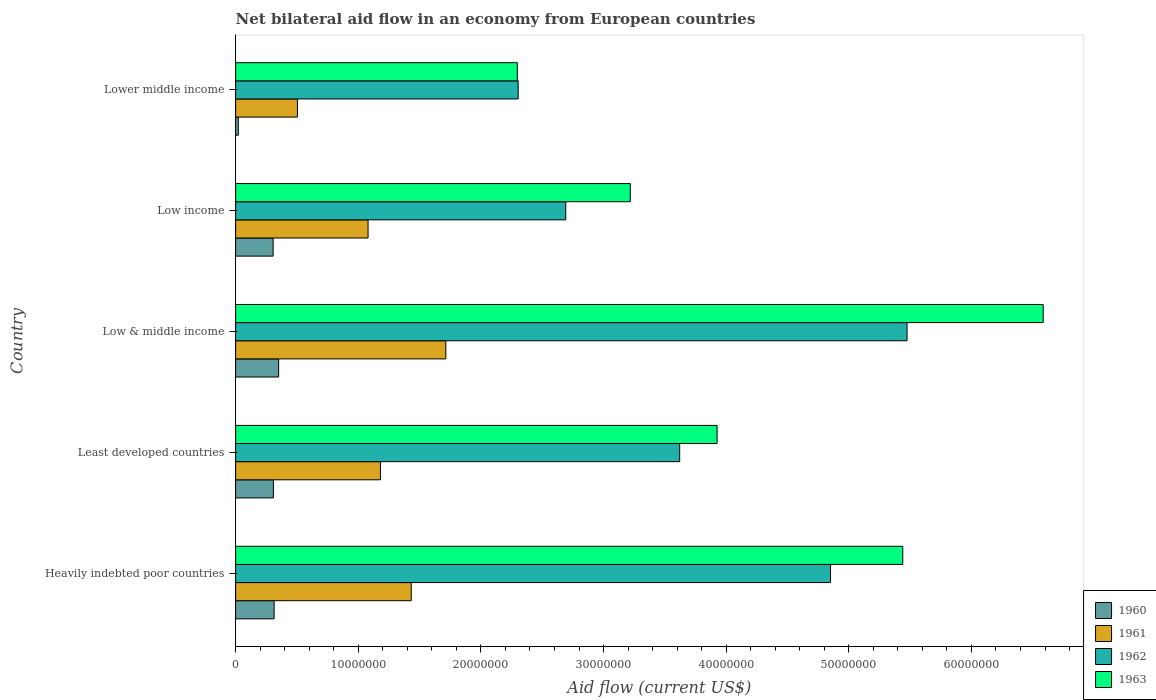How many different coloured bars are there?
Offer a terse response. 4. How many groups of bars are there?
Your answer should be compact. 5. Are the number of bars per tick equal to the number of legend labels?
Offer a terse response. Yes. Are the number of bars on each tick of the Y-axis equal?
Give a very brief answer. Yes. How many bars are there on the 5th tick from the top?
Make the answer very short. 4. In how many cases, is the number of bars for a given country not equal to the number of legend labels?
Make the answer very short. 0. What is the net bilateral aid flow in 1962 in Heavily indebted poor countries?
Offer a very short reply. 4.85e+07. Across all countries, what is the maximum net bilateral aid flow in 1963?
Provide a succinct answer. 6.58e+07. Across all countries, what is the minimum net bilateral aid flow in 1962?
Your answer should be compact. 2.30e+07. In which country was the net bilateral aid flow in 1961 minimum?
Give a very brief answer. Lower middle income. What is the total net bilateral aid flow in 1963 in the graph?
Keep it short and to the point. 2.15e+08. What is the difference between the net bilateral aid flow in 1960 in Least developed countries and that in Lower middle income?
Provide a succinct answer. 2.86e+06. What is the difference between the net bilateral aid flow in 1962 in Heavily indebted poor countries and the net bilateral aid flow in 1963 in Low & middle income?
Provide a succinct answer. -1.73e+07. What is the average net bilateral aid flow in 1963 per country?
Your answer should be very brief. 4.29e+07. What is the difference between the net bilateral aid flow in 1960 and net bilateral aid flow in 1962 in Low & middle income?
Make the answer very short. -5.12e+07. What is the ratio of the net bilateral aid flow in 1962 in Least developed countries to that in Low income?
Your response must be concise. 1.35. Is the difference between the net bilateral aid flow in 1960 in Least developed countries and Lower middle income greater than the difference between the net bilateral aid flow in 1962 in Least developed countries and Lower middle income?
Ensure brevity in your answer.  No. What is the difference between the highest and the second highest net bilateral aid flow in 1962?
Offer a terse response. 6.24e+06. What is the difference between the highest and the lowest net bilateral aid flow in 1960?
Your answer should be very brief. 3.29e+06. In how many countries, is the net bilateral aid flow in 1961 greater than the average net bilateral aid flow in 1961 taken over all countries?
Make the answer very short. 2. What does the 4th bar from the bottom in Low & middle income represents?
Offer a terse response. 1963. Is it the case that in every country, the sum of the net bilateral aid flow in 1962 and net bilateral aid flow in 1960 is greater than the net bilateral aid flow in 1963?
Ensure brevity in your answer.  No. Are all the bars in the graph horizontal?
Offer a terse response. Yes. What is the difference between two consecutive major ticks on the X-axis?
Your answer should be compact. 1.00e+07. Does the graph contain grids?
Keep it short and to the point. No. How many legend labels are there?
Make the answer very short. 4. How are the legend labels stacked?
Keep it short and to the point. Vertical. What is the title of the graph?
Your response must be concise. Net bilateral aid flow in an economy from European countries. What is the label or title of the X-axis?
Make the answer very short. Aid flow (current US$). What is the label or title of the Y-axis?
Ensure brevity in your answer.  Country. What is the Aid flow (current US$) of 1960 in Heavily indebted poor countries?
Provide a short and direct response. 3.14e+06. What is the Aid flow (current US$) of 1961 in Heavily indebted poor countries?
Offer a terse response. 1.43e+07. What is the Aid flow (current US$) in 1962 in Heavily indebted poor countries?
Ensure brevity in your answer.  4.85e+07. What is the Aid flow (current US$) in 1963 in Heavily indebted poor countries?
Your response must be concise. 5.44e+07. What is the Aid flow (current US$) of 1960 in Least developed countries?
Provide a short and direct response. 3.08e+06. What is the Aid flow (current US$) of 1961 in Least developed countries?
Provide a succinct answer. 1.18e+07. What is the Aid flow (current US$) of 1962 in Least developed countries?
Provide a short and direct response. 3.62e+07. What is the Aid flow (current US$) of 1963 in Least developed countries?
Offer a terse response. 3.93e+07. What is the Aid flow (current US$) in 1960 in Low & middle income?
Offer a terse response. 3.51e+06. What is the Aid flow (current US$) of 1961 in Low & middle income?
Provide a short and direct response. 1.71e+07. What is the Aid flow (current US$) in 1962 in Low & middle income?
Your response must be concise. 5.48e+07. What is the Aid flow (current US$) in 1963 in Low & middle income?
Your response must be concise. 6.58e+07. What is the Aid flow (current US$) of 1960 in Low income?
Your answer should be compact. 3.06e+06. What is the Aid flow (current US$) in 1961 in Low income?
Your answer should be compact. 1.08e+07. What is the Aid flow (current US$) of 1962 in Low income?
Ensure brevity in your answer.  2.69e+07. What is the Aid flow (current US$) in 1963 in Low income?
Your response must be concise. 3.22e+07. What is the Aid flow (current US$) in 1961 in Lower middle income?
Offer a terse response. 5.04e+06. What is the Aid flow (current US$) in 1962 in Lower middle income?
Provide a succinct answer. 2.30e+07. What is the Aid flow (current US$) of 1963 in Lower middle income?
Your answer should be very brief. 2.30e+07. Across all countries, what is the maximum Aid flow (current US$) in 1960?
Offer a very short reply. 3.51e+06. Across all countries, what is the maximum Aid flow (current US$) of 1961?
Ensure brevity in your answer.  1.71e+07. Across all countries, what is the maximum Aid flow (current US$) in 1962?
Your response must be concise. 5.48e+07. Across all countries, what is the maximum Aid flow (current US$) in 1963?
Offer a terse response. 6.58e+07. Across all countries, what is the minimum Aid flow (current US$) in 1960?
Offer a terse response. 2.20e+05. Across all countries, what is the minimum Aid flow (current US$) in 1961?
Offer a very short reply. 5.04e+06. Across all countries, what is the minimum Aid flow (current US$) of 1962?
Keep it short and to the point. 2.30e+07. Across all countries, what is the minimum Aid flow (current US$) of 1963?
Give a very brief answer. 2.30e+07. What is the total Aid flow (current US$) of 1960 in the graph?
Give a very brief answer. 1.30e+07. What is the total Aid flow (current US$) in 1961 in the graph?
Your answer should be very brief. 5.91e+07. What is the total Aid flow (current US$) of 1962 in the graph?
Ensure brevity in your answer.  1.89e+08. What is the total Aid flow (current US$) in 1963 in the graph?
Your response must be concise. 2.15e+08. What is the difference between the Aid flow (current US$) of 1961 in Heavily indebted poor countries and that in Least developed countries?
Offer a terse response. 2.51e+06. What is the difference between the Aid flow (current US$) of 1962 in Heavily indebted poor countries and that in Least developed countries?
Offer a terse response. 1.23e+07. What is the difference between the Aid flow (current US$) of 1963 in Heavily indebted poor countries and that in Least developed countries?
Provide a short and direct response. 1.51e+07. What is the difference between the Aid flow (current US$) in 1960 in Heavily indebted poor countries and that in Low & middle income?
Give a very brief answer. -3.70e+05. What is the difference between the Aid flow (current US$) in 1961 in Heavily indebted poor countries and that in Low & middle income?
Provide a short and direct response. -2.82e+06. What is the difference between the Aid flow (current US$) of 1962 in Heavily indebted poor countries and that in Low & middle income?
Make the answer very short. -6.24e+06. What is the difference between the Aid flow (current US$) in 1963 in Heavily indebted poor countries and that in Low & middle income?
Give a very brief answer. -1.14e+07. What is the difference between the Aid flow (current US$) in 1961 in Heavily indebted poor countries and that in Low income?
Give a very brief answer. 3.52e+06. What is the difference between the Aid flow (current US$) of 1962 in Heavily indebted poor countries and that in Low income?
Offer a terse response. 2.16e+07. What is the difference between the Aid flow (current US$) of 1963 in Heavily indebted poor countries and that in Low income?
Keep it short and to the point. 2.22e+07. What is the difference between the Aid flow (current US$) of 1960 in Heavily indebted poor countries and that in Lower middle income?
Provide a succinct answer. 2.92e+06. What is the difference between the Aid flow (current US$) in 1961 in Heavily indebted poor countries and that in Lower middle income?
Offer a very short reply. 9.28e+06. What is the difference between the Aid flow (current US$) of 1962 in Heavily indebted poor countries and that in Lower middle income?
Make the answer very short. 2.55e+07. What is the difference between the Aid flow (current US$) in 1963 in Heavily indebted poor countries and that in Lower middle income?
Make the answer very short. 3.14e+07. What is the difference between the Aid flow (current US$) in 1960 in Least developed countries and that in Low & middle income?
Provide a succinct answer. -4.30e+05. What is the difference between the Aid flow (current US$) of 1961 in Least developed countries and that in Low & middle income?
Ensure brevity in your answer.  -5.33e+06. What is the difference between the Aid flow (current US$) in 1962 in Least developed countries and that in Low & middle income?
Offer a very short reply. -1.85e+07. What is the difference between the Aid flow (current US$) of 1963 in Least developed countries and that in Low & middle income?
Your response must be concise. -2.66e+07. What is the difference between the Aid flow (current US$) in 1960 in Least developed countries and that in Low income?
Give a very brief answer. 2.00e+04. What is the difference between the Aid flow (current US$) in 1961 in Least developed countries and that in Low income?
Provide a succinct answer. 1.01e+06. What is the difference between the Aid flow (current US$) in 1962 in Least developed countries and that in Low income?
Your answer should be very brief. 9.29e+06. What is the difference between the Aid flow (current US$) in 1963 in Least developed countries and that in Low income?
Keep it short and to the point. 7.08e+06. What is the difference between the Aid flow (current US$) of 1960 in Least developed countries and that in Lower middle income?
Your response must be concise. 2.86e+06. What is the difference between the Aid flow (current US$) in 1961 in Least developed countries and that in Lower middle income?
Your response must be concise. 6.77e+06. What is the difference between the Aid flow (current US$) in 1962 in Least developed countries and that in Lower middle income?
Keep it short and to the point. 1.32e+07. What is the difference between the Aid flow (current US$) of 1963 in Least developed countries and that in Lower middle income?
Provide a short and direct response. 1.63e+07. What is the difference between the Aid flow (current US$) in 1960 in Low & middle income and that in Low income?
Your answer should be compact. 4.50e+05. What is the difference between the Aid flow (current US$) in 1961 in Low & middle income and that in Low income?
Ensure brevity in your answer.  6.34e+06. What is the difference between the Aid flow (current US$) in 1962 in Low & middle income and that in Low income?
Your response must be concise. 2.78e+07. What is the difference between the Aid flow (current US$) in 1963 in Low & middle income and that in Low income?
Make the answer very short. 3.37e+07. What is the difference between the Aid flow (current US$) of 1960 in Low & middle income and that in Lower middle income?
Your answer should be compact. 3.29e+06. What is the difference between the Aid flow (current US$) in 1961 in Low & middle income and that in Lower middle income?
Your response must be concise. 1.21e+07. What is the difference between the Aid flow (current US$) in 1962 in Low & middle income and that in Lower middle income?
Your answer should be compact. 3.17e+07. What is the difference between the Aid flow (current US$) of 1963 in Low & middle income and that in Lower middle income?
Offer a terse response. 4.29e+07. What is the difference between the Aid flow (current US$) of 1960 in Low income and that in Lower middle income?
Ensure brevity in your answer.  2.84e+06. What is the difference between the Aid flow (current US$) of 1961 in Low income and that in Lower middle income?
Keep it short and to the point. 5.76e+06. What is the difference between the Aid flow (current US$) in 1962 in Low income and that in Lower middle income?
Your answer should be very brief. 3.88e+06. What is the difference between the Aid flow (current US$) in 1963 in Low income and that in Lower middle income?
Offer a terse response. 9.21e+06. What is the difference between the Aid flow (current US$) in 1960 in Heavily indebted poor countries and the Aid flow (current US$) in 1961 in Least developed countries?
Your answer should be compact. -8.67e+06. What is the difference between the Aid flow (current US$) of 1960 in Heavily indebted poor countries and the Aid flow (current US$) of 1962 in Least developed countries?
Your answer should be compact. -3.31e+07. What is the difference between the Aid flow (current US$) of 1960 in Heavily indebted poor countries and the Aid flow (current US$) of 1963 in Least developed countries?
Give a very brief answer. -3.61e+07. What is the difference between the Aid flow (current US$) in 1961 in Heavily indebted poor countries and the Aid flow (current US$) in 1962 in Least developed countries?
Your answer should be compact. -2.19e+07. What is the difference between the Aid flow (current US$) in 1961 in Heavily indebted poor countries and the Aid flow (current US$) in 1963 in Least developed countries?
Offer a terse response. -2.49e+07. What is the difference between the Aid flow (current US$) in 1962 in Heavily indebted poor countries and the Aid flow (current US$) in 1963 in Least developed countries?
Offer a very short reply. 9.25e+06. What is the difference between the Aid flow (current US$) of 1960 in Heavily indebted poor countries and the Aid flow (current US$) of 1961 in Low & middle income?
Provide a short and direct response. -1.40e+07. What is the difference between the Aid flow (current US$) of 1960 in Heavily indebted poor countries and the Aid flow (current US$) of 1962 in Low & middle income?
Your answer should be compact. -5.16e+07. What is the difference between the Aid flow (current US$) in 1960 in Heavily indebted poor countries and the Aid flow (current US$) in 1963 in Low & middle income?
Ensure brevity in your answer.  -6.27e+07. What is the difference between the Aid flow (current US$) in 1961 in Heavily indebted poor countries and the Aid flow (current US$) in 1962 in Low & middle income?
Provide a short and direct response. -4.04e+07. What is the difference between the Aid flow (current US$) of 1961 in Heavily indebted poor countries and the Aid flow (current US$) of 1963 in Low & middle income?
Provide a succinct answer. -5.15e+07. What is the difference between the Aid flow (current US$) of 1962 in Heavily indebted poor countries and the Aid flow (current US$) of 1963 in Low & middle income?
Your answer should be very brief. -1.73e+07. What is the difference between the Aid flow (current US$) in 1960 in Heavily indebted poor countries and the Aid flow (current US$) in 1961 in Low income?
Give a very brief answer. -7.66e+06. What is the difference between the Aid flow (current US$) in 1960 in Heavily indebted poor countries and the Aid flow (current US$) in 1962 in Low income?
Your answer should be compact. -2.38e+07. What is the difference between the Aid flow (current US$) of 1960 in Heavily indebted poor countries and the Aid flow (current US$) of 1963 in Low income?
Give a very brief answer. -2.90e+07. What is the difference between the Aid flow (current US$) of 1961 in Heavily indebted poor countries and the Aid flow (current US$) of 1962 in Low income?
Your answer should be compact. -1.26e+07. What is the difference between the Aid flow (current US$) of 1961 in Heavily indebted poor countries and the Aid flow (current US$) of 1963 in Low income?
Provide a succinct answer. -1.79e+07. What is the difference between the Aid flow (current US$) in 1962 in Heavily indebted poor countries and the Aid flow (current US$) in 1963 in Low income?
Ensure brevity in your answer.  1.63e+07. What is the difference between the Aid flow (current US$) in 1960 in Heavily indebted poor countries and the Aid flow (current US$) in 1961 in Lower middle income?
Provide a short and direct response. -1.90e+06. What is the difference between the Aid flow (current US$) of 1960 in Heavily indebted poor countries and the Aid flow (current US$) of 1962 in Lower middle income?
Ensure brevity in your answer.  -1.99e+07. What is the difference between the Aid flow (current US$) of 1960 in Heavily indebted poor countries and the Aid flow (current US$) of 1963 in Lower middle income?
Provide a succinct answer. -1.98e+07. What is the difference between the Aid flow (current US$) of 1961 in Heavily indebted poor countries and the Aid flow (current US$) of 1962 in Lower middle income?
Provide a short and direct response. -8.72e+06. What is the difference between the Aid flow (current US$) of 1961 in Heavily indebted poor countries and the Aid flow (current US$) of 1963 in Lower middle income?
Your answer should be compact. -8.65e+06. What is the difference between the Aid flow (current US$) in 1962 in Heavily indebted poor countries and the Aid flow (current US$) in 1963 in Lower middle income?
Ensure brevity in your answer.  2.55e+07. What is the difference between the Aid flow (current US$) in 1960 in Least developed countries and the Aid flow (current US$) in 1961 in Low & middle income?
Offer a terse response. -1.41e+07. What is the difference between the Aid flow (current US$) of 1960 in Least developed countries and the Aid flow (current US$) of 1962 in Low & middle income?
Ensure brevity in your answer.  -5.17e+07. What is the difference between the Aid flow (current US$) in 1960 in Least developed countries and the Aid flow (current US$) in 1963 in Low & middle income?
Make the answer very short. -6.28e+07. What is the difference between the Aid flow (current US$) of 1961 in Least developed countries and the Aid flow (current US$) of 1962 in Low & middle income?
Provide a short and direct response. -4.29e+07. What is the difference between the Aid flow (current US$) in 1961 in Least developed countries and the Aid flow (current US$) in 1963 in Low & middle income?
Your answer should be very brief. -5.40e+07. What is the difference between the Aid flow (current US$) of 1962 in Least developed countries and the Aid flow (current US$) of 1963 in Low & middle income?
Your answer should be compact. -2.96e+07. What is the difference between the Aid flow (current US$) of 1960 in Least developed countries and the Aid flow (current US$) of 1961 in Low income?
Make the answer very short. -7.72e+06. What is the difference between the Aid flow (current US$) in 1960 in Least developed countries and the Aid flow (current US$) in 1962 in Low income?
Offer a terse response. -2.38e+07. What is the difference between the Aid flow (current US$) of 1960 in Least developed countries and the Aid flow (current US$) of 1963 in Low income?
Keep it short and to the point. -2.91e+07. What is the difference between the Aid flow (current US$) of 1961 in Least developed countries and the Aid flow (current US$) of 1962 in Low income?
Provide a succinct answer. -1.51e+07. What is the difference between the Aid flow (current US$) in 1961 in Least developed countries and the Aid flow (current US$) in 1963 in Low income?
Keep it short and to the point. -2.04e+07. What is the difference between the Aid flow (current US$) in 1962 in Least developed countries and the Aid flow (current US$) in 1963 in Low income?
Your answer should be very brief. 4.03e+06. What is the difference between the Aid flow (current US$) of 1960 in Least developed countries and the Aid flow (current US$) of 1961 in Lower middle income?
Give a very brief answer. -1.96e+06. What is the difference between the Aid flow (current US$) in 1960 in Least developed countries and the Aid flow (current US$) in 1962 in Lower middle income?
Ensure brevity in your answer.  -2.00e+07. What is the difference between the Aid flow (current US$) of 1960 in Least developed countries and the Aid flow (current US$) of 1963 in Lower middle income?
Offer a very short reply. -1.99e+07. What is the difference between the Aid flow (current US$) of 1961 in Least developed countries and the Aid flow (current US$) of 1962 in Lower middle income?
Provide a succinct answer. -1.12e+07. What is the difference between the Aid flow (current US$) of 1961 in Least developed countries and the Aid flow (current US$) of 1963 in Lower middle income?
Make the answer very short. -1.12e+07. What is the difference between the Aid flow (current US$) in 1962 in Least developed countries and the Aid flow (current US$) in 1963 in Lower middle income?
Provide a short and direct response. 1.32e+07. What is the difference between the Aid flow (current US$) of 1960 in Low & middle income and the Aid flow (current US$) of 1961 in Low income?
Your response must be concise. -7.29e+06. What is the difference between the Aid flow (current US$) of 1960 in Low & middle income and the Aid flow (current US$) of 1962 in Low income?
Provide a short and direct response. -2.34e+07. What is the difference between the Aid flow (current US$) of 1960 in Low & middle income and the Aid flow (current US$) of 1963 in Low income?
Make the answer very short. -2.87e+07. What is the difference between the Aid flow (current US$) in 1961 in Low & middle income and the Aid flow (current US$) in 1962 in Low income?
Give a very brief answer. -9.78e+06. What is the difference between the Aid flow (current US$) of 1961 in Low & middle income and the Aid flow (current US$) of 1963 in Low income?
Your answer should be compact. -1.50e+07. What is the difference between the Aid flow (current US$) of 1962 in Low & middle income and the Aid flow (current US$) of 1963 in Low income?
Ensure brevity in your answer.  2.26e+07. What is the difference between the Aid flow (current US$) of 1960 in Low & middle income and the Aid flow (current US$) of 1961 in Lower middle income?
Your response must be concise. -1.53e+06. What is the difference between the Aid flow (current US$) of 1960 in Low & middle income and the Aid flow (current US$) of 1962 in Lower middle income?
Offer a terse response. -1.95e+07. What is the difference between the Aid flow (current US$) of 1960 in Low & middle income and the Aid flow (current US$) of 1963 in Lower middle income?
Give a very brief answer. -1.95e+07. What is the difference between the Aid flow (current US$) in 1961 in Low & middle income and the Aid flow (current US$) in 1962 in Lower middle income?
Make the answer very short. -5.90e+06. What is the difference between the Aid flow (current US$) in 1961 in Low & middle income and the Aid flow (current US$) in 1963 in Lower middle income?
Your answer should be compact. -5.83e+06. What is the difference between the Aid flow (current US$) of 1962 in Low & middle income and the Aid flow (current US$) of 1963 in Lower middle income?
Your answer should be compact. 3.18e+07. What is the difference between the Aid flow (current US$) of 1960 in Low income and the Aid flow (current US$) of 1961 in Lower middle income?
Provide a short and direct response. -1.98e+06. What is the difference between the Aid flow (current US$) in 1960 in Low income and the Aid flow (current US$) in 1962 in Lower middle income?
Ensure brevity in your answer.  -2.00e+07. What is the difference between the Aid flow (current US$) of 1960 in Low income and the Aid flow (current US$) of 1963 in Lower middle income?
Offer a terse response. -1.99e+07. What is the difference between the Aid flow (current US$) of 1961 in Low income and the Aid flow (current US$) of 1962 in Lower middle income?
Your answer should be very brief. -1.22e+07. What is the difference between the Aid flow (current US$) of 1961 in Low income and the Aid flow (current US$) of 1963 in Lower middle income?
Make the answer very short. -1.22e+07. What is the difference between the Aid flow (current US$) of 1962 in Low income and the Aid flow (current US$) of 1963 in Lower middle income?
Give a very brief answer. 3.95e+06. What is the average Aid flow (current US$) of 1960 per country?
Keep it short and to the point. 2.60e+06. What is the average Aid flow (current US$) of 1961 per country?
Make the answer very short. 1.18e+07. What is the average Aid flow (current US$) in 1962 per country?
Your answer should be compact. 3.79e+07. What is the average Aid flow (current US$) in 1963 per country?
Offer a terse response. 4.29e+07. What is the difference between the Aid flow (current US$) in 1960 and Aid flow (current US$) in 1961 in Heavily indebted poor countries?
Give a very brief answer. -1.12e+07. What is the difference between the Aid flow (current US$) in 1960 and Aid flow (current US$) in 1962 in Heavily indebted poor countries?
Give a very brief answer. -4.54e+07. What is the difference between the Aid flow (current US$) of 1960 and Aid flow (current US$) of 1963 in Heavily indebted poor countries?
Offer a very short reply. -5.13e+07. What is the difference between the Aid flow (current US$) of 1961 and Aid flow (current US$) of 1962 in Heavily indebted poor countries?
Make the answer very short. -3.42e+07. What is the difference between the Aid flow (current US$) in 1961 and Aid flow (current US$) in 1963 in Heavily indebted poor countries?
Your answer should be compact. -4.01e+07. What is the difference between the Aid flow (current US$) in 1962 and Aid flow (current US$) in 1963 in Heavily indebted poor countries?
Offer a terse response. -5.89e+06. What is the difference between the Aid flow (current US$) of 1960 and Aid flow (current US$) of 1961 in Least developed countries?
Keep it short and to the point. -8.73e+06. What is the difference between the Aid flow (current US$) in 1960 and Aid flow (current US$) in 1962 in Least developed countries?
Provide a short and direct response. -3.31e+07. What is the difference between the Aid flow (current US$) in 1960 and Aid flow (current US$) in 1963 in Least developed countries?
Keep it short and to the point. -3.62e+07. What is the difference between the Aid flow (current US$) in 1961 and Aid flow (current US$) in 1962 in Least developed countries?
Provide a short and direct response. -2.44e+07. What is the difference between the Aid flow (current US$) in 1961 and Aid flow (current US$) in 1963 in Least developed countries?
Ensure brevity in your answer.  -2.74e+07. What is the difference between the Aid flow (current US$) in 1962 and Aid flow (current US$) in 1963 in Least developed countries?
Your answer should be very brief. -3.05e+06. What is the difference between the Aid flow (current US$) in 1960 and Aid flow (current US$) in 1961 in Low & middle income?
Keep it short and to the point. -1.36e+07. What is the difference between the Aid flow (current US$) in 1960 and Aid flow (current US$) in 1962 in Low & middle income?
Your answer should be compact. -5.12e+07. What is the difference between the Aid flow (current US$) of 1960 and Aid flow (current US$) of 1963 in Low & middle income?
Make the answer very short. -6.23e+07. What is the difference between the Aid flow (current US$) of 1961 and Aid flow (current US$) of 1962 in Low & middle income?
Offer a terse response. -3.76e+07. What is the difference between the Aid flow (current US$) in 1961 and Aid flow (current US$) in 1963 in Low & middle income?
Provide a succinct answer. -4.87e+07. What is the difference between the Aid flow (current US$) of 1962 and Aid flow (current US$) of 1963 in Low & middle income?
Your response must be concise. -1.11e+07. What is the difference between the Aid flow (current US$) in 1960 and Aid flow (current US$) in 1961 in Low income?
Make the answer very short. -7.74e+06. What is the difference between the Aid flow (current US$) in 1960 and Aid flow (current US$) in 1962 in Low income?
Provide a short and direct response. -2.39e+07. What is the difference between the Aid flow (current US$) in 1960 and Aid flow (current US$) in 1963 in Low income?
Offer a very short reply. -2.91e+07. What is the difference between the Aid flow (current US$) of 1961 and Aid flow (current US$) of 1962 in Low income?
Offer a terse response. -1.61e+07. What is the difference between the Aid flow (current US$) of 1961 and Aid flow (current US$) of 1963 in Low income?
Your response must be concise. -2.14e+07. What is the difference between the Aid flow (current US$) in 1962 and Aid flow (current US$) in 1963 in Low income?
Offer a very short reply. -5.26e+06. What is the difference between the Aid flow (current US$) of 1960 and Aid flow (current US$) of 1961 in Lower middle income?
Your answer should be very brief. -4.82e+06. What is the difference between the Aid flow (current US$) in 1960 and Aid flow (current US$) in 1962 in Lower middle income?
Provide a succinct answer. -2.28e+07. What is the difference between the Aid flow (current US$) in 1960 and Aid flow (current US$) in 1963 in Lower middle income?
Make the answer very short. -2.28e+07. What is the difference between the Aid flow (current US$) in 1961 and Aid flow (current US$) in 1962 in Lower middle income?
Your answer should be compact. -1.80e+07. What is the difference between the Aid flow (current US$) of 1961 and Aid flow (current US$) of 1963 in Lower middle income?
Provide a short and direct response. -1.79e+07. What is the difference between the Aid flow (current US$) of 1962 and Aid flow (current US$) of 1963 in Lower middle income?
Provide a short and direct response. 7.00e+04. What is the ratio of the Aid flow (current US$) of 1960 in Heavily indebted poor countries to that in Least developed countries?
Keep it short and to the point. 1.02. What is the ratio of the Aid flow (current US$) in 1961 in Heavily indebted poor countries to that in Least developed countries?
Your response must be concise. 1.21. What is the ratio of the Aid flow (current US$) in 1962 in Heavily indebted poor countries to that in Least developed countries?
Keep it short and to the point. 1.34. What is the ratio of the Aid flow (current US$) of 1963 in Heavily indebted poor countries to that in Least developed countries?
Give a very brief answer. 1.39. What is the ratio of the Aid flow (current US$) of 1960 in Heavily indebted poor countries to that in Low & middle income?
Your response must be concise. 0.89. What is the ratio of the Aid flow (current US$) in 1961 in Heavily indebted poor countries to that in Low & middle income?
Ensure brevity in your answer.  0.84. What is the ratio of the Aid flow (current US$) of 1962 in Heavily indebted poor countries to that in Low & middle income?
Keep it short and to the point. 0.89. What is the ratio of the Aid flow (current US$) in 1963 in Heavily indebted poor countries to that in Low & middle income?
Your response must be concise. 0.83. What is the ratio of the Aid flow (current US$) in 1960 in Heavily indebted poor countries to that in Low income?
Your response must be concise. 1.03. What is the ratio of the Aid flow (current US$) of 1961 in Heavily indebted poor countries to that in Low income?
Offer a terse response. 1.33. What is the ratio of the Aid flow (current US$) of 1962 in Heavily indebted poor countries to that in Low income?
Provide a succinct answer. 1.8. What is the ratio of the Aid flow (current US$) of 1963 in Heavily indebted poor countries to that in Low income?
Your answer should be very brief. 1.69. What is the ratio of the Aid flow (current US$) of 1960 in Heavily indebted poor countries to that in Lower middle income?
Provide a short and direct response. 14.27. What is the ratio of the Aid flow (current US$) of 1961 in Heavily indebted poor countries to that in Lower middle income?
Provide a succinct answer. 2.84. What is the ratio of the Aid flow (current US$) of 1962 in Heavily indebted poor countries to that in Lower middle income?
Offer a terse response. 2.11. What is the ratio of the Aid flow (current US$) of 1963 in Heavily indebted poor countries to that in Lower middle income?
Give a very brief answer. 2.37. What is the ratio of the Aid flow (current US$) in 1960 in Least developed countries to that in Low & middle income?
Your answer should be very brief. 0.88. What is the ratio of the Aid flow (current US$) in 1961 in Least developed countries to that in Low & middle income?
Your answer should be very brief. 0.69. What is the ratio of the Aid flow (current US$) of 1962 in Least developed countries to that in Low & middle income?
Provide a succinct answer. 0.66. What is the ratio of the Aid flow (current US$) in 1963 in Least developed countries to that in Low & middle income?
Offer a very short reply. 0.6. What is the ratio of the Aid flow (current US$) in 1960 in Least developed countries to that in Low income?
Your answer should be very brief. 1.01. What is the ratio of the Aid flow (current US$) of 1961 in Least developed countries to that in Low income?
Provide a short and direct response. 1.09. What is the ratio of the Aid flow (current US$) in 1962 in Least developed countries to that in Low income?
Your response must be concise. 1.35. What is the ratio of the Aid flow (current US$) in 1963 in Least developed countries to that in Low income?
Make the answer very short. 1.22. What is the ratio of the Aid flow (current US$) of 1960 in Least developed countries to that in Lower middle income?
Keep it short and to the point. 14. What is the ratio of the Aid flow (current US$) in 1961 in Least developed countries to that in Lower middle income?
Give a very brief answer. 2.34. What is the ratio of the Aid flow (current US$) in 1962 in Least developed countries to that in Lower middle income?
Make the answer very short. 1.57. What is the ratio of the Aid flow (current US$) in 1963 in Least developed countries to that in Lower middle income?
Keep it short and to the point. 1.71. What is the ratio of the Aid flow (current US$) of 1960 in Low & middle income to that in Low income?
Provide a succinct answer. 1.15. What is the ratio of the Aid flow (current US$) of 1961 in Low & middle income to that in Low income?
Offer a terse response. 1.59. What is the ratio of the Aid flow (current US$) of 1962 in Low & middle income to that in Low income?
Make the answer very short. 2.03. What is the ratio of the Aid flow (current US$) in 1963 in Low & middle income to that in Low income?
Your answer should be very brief. 2.05. What is the ratio of the Aid flow (current US$) of 1960 in Low & middle income to that in Lower middle income?
Your response must be concise. 15.95. What is the ratio of the Aid flow (current US$) of 1961 in Low & middle income to that in Lower middle income?
Give a very brief answer. 3.4. What is the ratio of the Aid flow (current US$) of 1962 in Low & middle income to that in Lower middle income?
Your answer should be very brief. 2.38. What is the ratio of the Aid flow (current US$) of 1963 in Low & middle income to that in Lower middle income?
Your answer should be very brief. 2.87. What is the ratio of the Aid flow (current US$) of 1960 in Low income to that in Lower middle income?
Your response must be concise. 13.91. What is the ratio of the Aid flow (current US$) of 1961 in Low income to that in Lower middle income?
Your answer should be compact. 2.14. What is the ratio of the Aid flow (current US$) of 1962 in Low income to that in Lower middle income?
Ensure brevity in your answer.  1.17. What is the ratio of the Aid flow (current US$) in 1963 in Low income to that in Lower middle income?
Keep it short and to the point. 1.4. What is the difference between the highest and the second highest Aid flow (current US$) of 1961?
Your answer should be very brief. 2.82e+06. What is the difference between the highest and the second highest Aid flow (current US$) in 1962?
Give a very brief answer. 6.24e+06. What is the difference between the highest and the second highest Aid flow (current US$) of 1963?
Give a very brief answer. 1.14e+07. What is the difference between the highest and the lowest Aid flow (current US$) in 1960?
Your answer should be compact. 3.29e+06. What is the difference between the highest and the lowest Aid flow (current US$) in 1961?
Offer a very short reply. 1.21e+07. What is the difference between the highest and the lowest Aid flow (current US$) in 1962?
Ensure brevity in your answer.  3.17e+07. What is the difference between the highest and the lowest Aid flow (current US$) in 1963?
Offer a very short reply. 4.29e+07. 